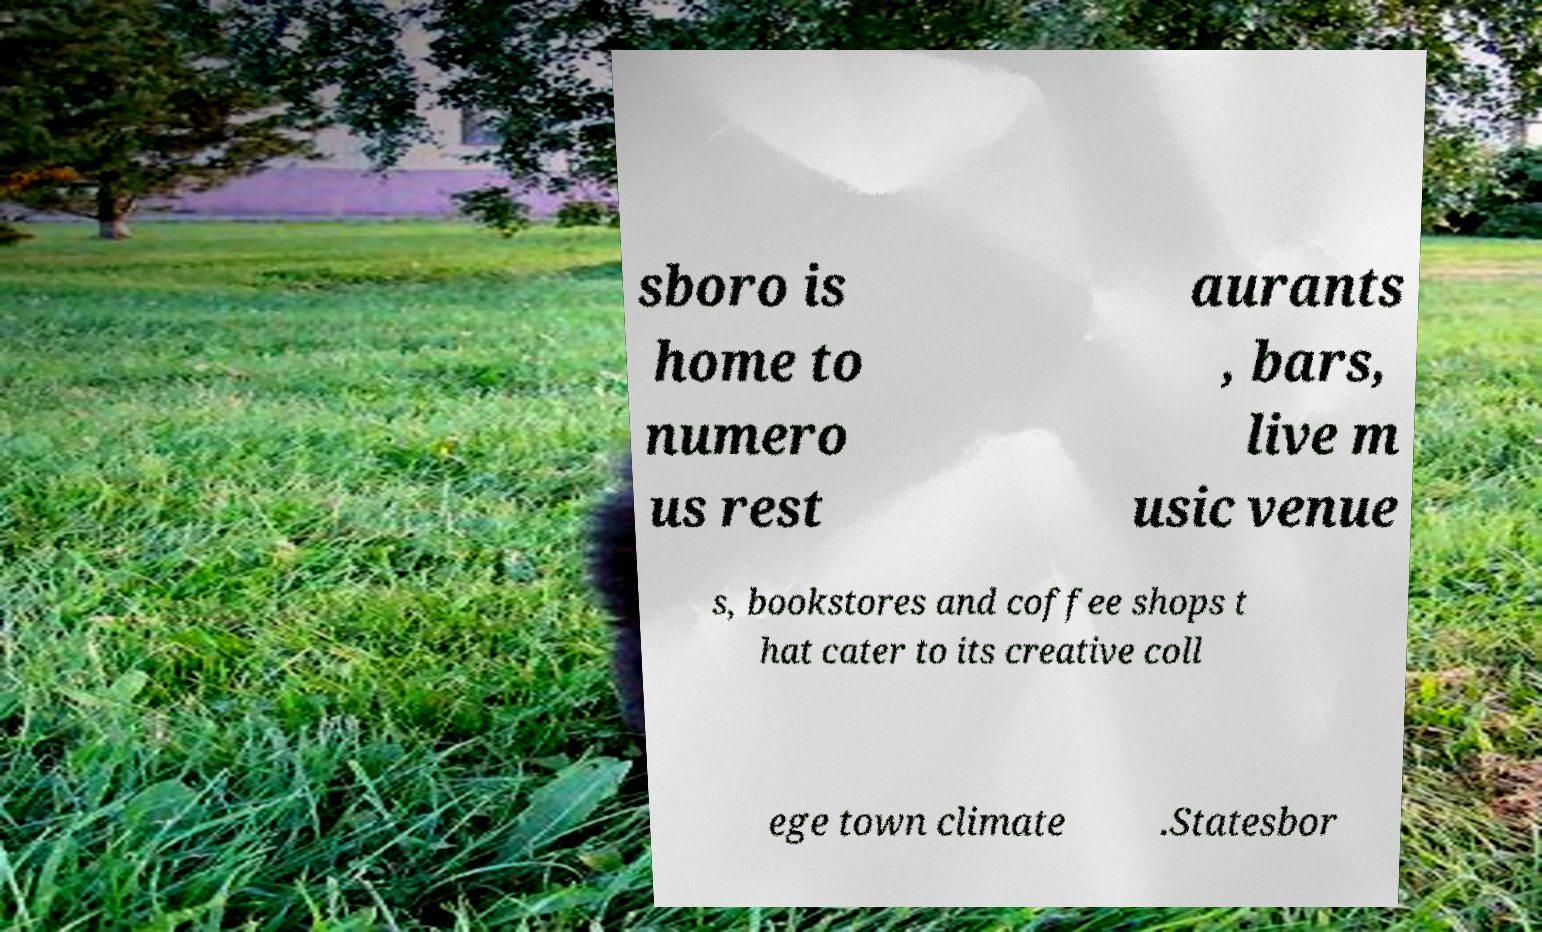Could you extract and type out the text from this image? sboro is home to numero us rest aurants , bars, live m usic venue s, bookstores and coffee shops t hat cater to its creative coll ege town climate .Statesbor 